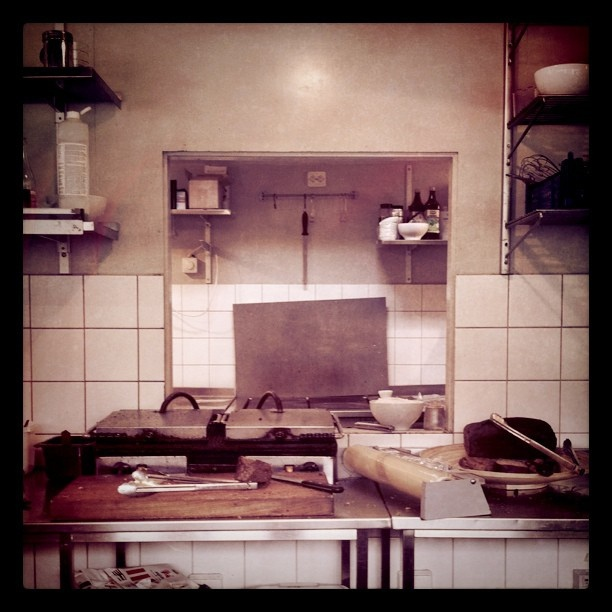Describe the objects in this image and their specific colors. I can see cake in black, purple, gray, and brown tones, bottle in black, gray, darkgray, and brown tones, bowl in black, tan, salmon, gray, and lightgray tones, cup in black, brown, lightpink, and salmon tones, and bowl in black, gray, brown, and maroon tones in this image. 